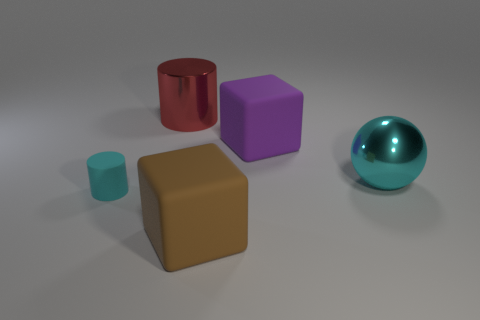How many other things are there of the same size as the brown block?
Give a very brief answer. 3. There is a big metal thing that is behind the purple rubber cube; what number of large objects are to the left of it?
Your answer should be compact. 0. Is the number of cyan rubber cylinders in front of the small cyan thing less than the number of large blue shiny things?
Give a very brief answer. No. What is the shape of the cyan object to the right of the cylinder that is behind the cyan cylinder that is in front of the big purple rubber block?
Your answer should be very brief. Sphere. Is the tiny object the same shape as the red object?
Your answer should be very brief. Yes. How many other things are there of the same shape as the large red thing?
Offer a very short reply. 1. The shiny cylinder that is the same size as the purple rubber thing is what color?
Ensure brevity in your answer.  Red. Is the number of tiny objects behind the big red metallic cylinder the same as the number of big blue matte blocks?
Ensure brevity in your answer.  Yes. What is the shape of the object that is both on the left side of the brown matte object and on the right side of the tiny object?
Make the answer very short. Cylinder. Does the brown block have the same size as the cyan metallic thing?
Ensure brevity in your answer.  Yes. 